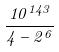<formula> <loc_0><loc_0><loc_500><loc_500>\frac { 1 0 ^ { 1 4 3 } } { 4 - 2 ^ { 6 } }</formula> 